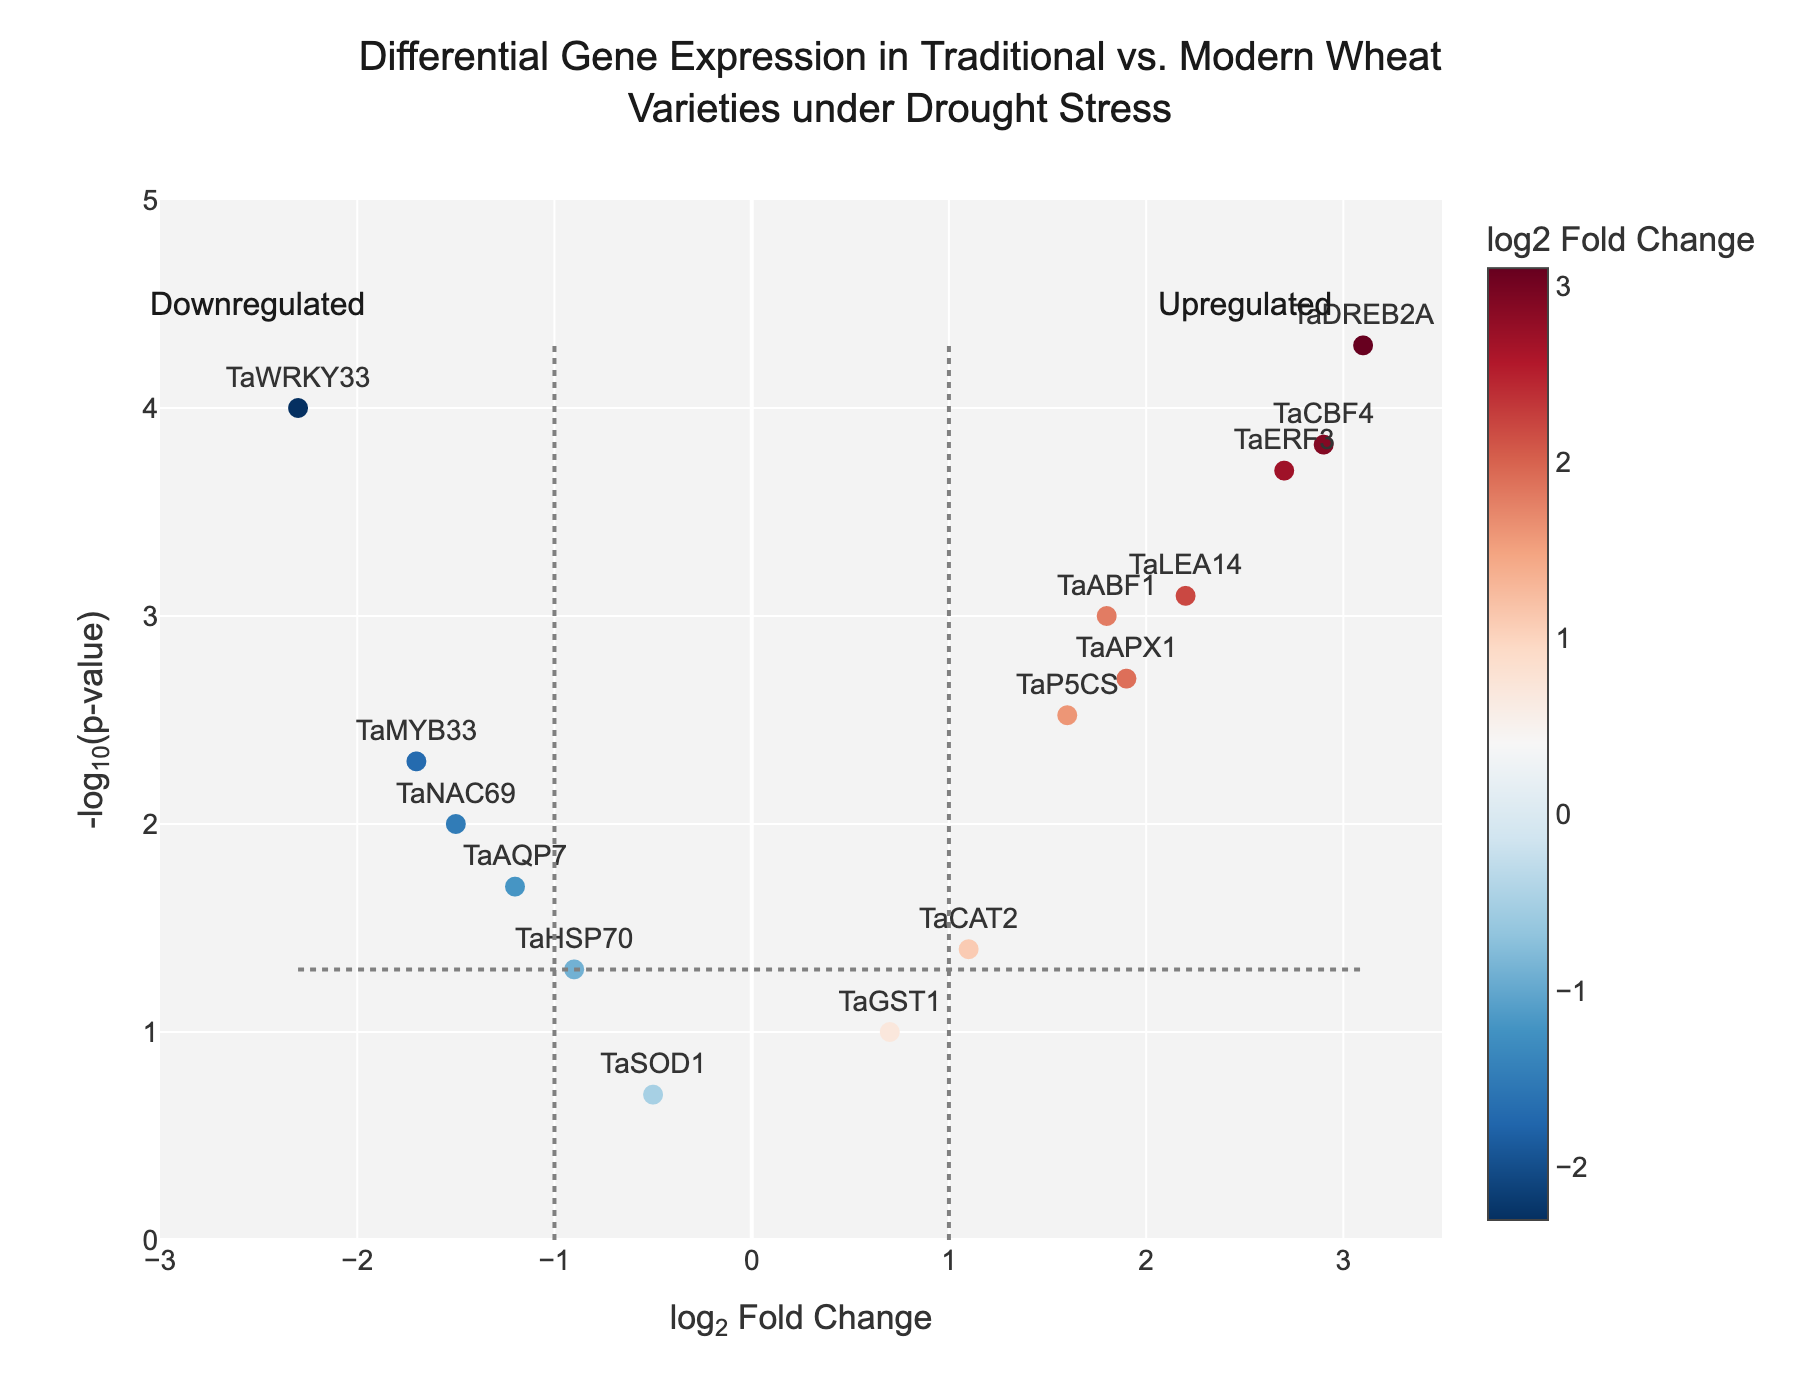What does the figure title suggest about the data? The figure title indicates that the volcano plot shows the differential gene expression in traditional and modern wheat varieties under drought stress. The title suggests a comparative analysis between the two types of wheat regarding their response to drought stress at the genetic level.
Answer: Differential gene expression in traditional vs. modern wheat under drought stress What is the x-axis title, and what does it represent? The x-axis title is "log2 Fold Change," which represents the logarithmic ratio (base 2) of the expression levels of genes between traditional and modern wheat varieties. Genes with positive values are upregulated in traditional wheat, while those with negative values are downregulated.
Answer: log2 Fold Change What threshold is used for the p-value significance, and how is it represented in the plot? The threshold for the p-value significance is 0.05, represented by a horizontal dashed line at -log10(0.05). This line distinguishes significantly differentially expressed genes from non-significant ones.
Answer: Horizontal dashed line at -log10(0.05) How many genes are upregulated with a significance level below 0.05? To find this, locate genes with a log2FoldChange greater than 0 and a -log10(pvalue) above the dashed horizontal line at -log10(0.05). The genes satisfying these criteria are TaDREB2A, TaERF3, TaLEA14, TaCBF4, TaAPX1, and TaABF1.
Answer: 6 Which gene has the highest log2FoldChange and what is its corresponding p-value? To identify this, find the gene with the highest positive log2FoldChange value. TaDREB2A has the highest log2FoldChange of 3.1. Its p-value, according to the hover information, is 0.00005.
Answer: TaDREB2A, 0.00005 Identify the gene with the lowest log2FoldChange and describe its significance. The gene with the lowest log2FoldChange is TaWRKY33 with a value of -2.3. To determine its significance, look at its -log10(pvalue), which is above the significance threshold line, indicating it is significantly downregulated.
Answer: TaWRKY33, significant What does the color gradient indicate in this volcano plot? The color gradient represents the log2FoldChange values. Genes with higher positive log2FoldChange are in shades of red, while those with negative log2FoldChange are in shades of blue, indicating upregulation and downregulation, respectively.
Answer: log2FoldChange How many genes have a p-value greater than 0.05 and what are their names? Identify genes with a -log10(pvalue) below the horizontal dashed line at -log10(0.05). The genes are TaHSP70, TaAQP7, TaGST1, and TaSOD1.
Answer: 4: TaHSP70, TaAQP7, TaGST1, TaSOD1 What does the label "Upregulated" indicate, and where is it placed in the plot? The label "Upregulated" indicates the area of the plot where genes are more highly expressed in traditional wheat compared to modern wheat. It is placed near the top right corner, above genes with high positive log2FoldChange.
Answer: Top right corner Compare the expression of TaMYB33 and TaNAC69, indicating which one is more significantly downregulated. TaMYB33 has a log2FoldChange of -1.7 with a lower p-value, making it more significantly downregulated than TaNAC69, which has a log2FoldChange of -1.5 but a higher p-value.
Answer: TaMYB33 